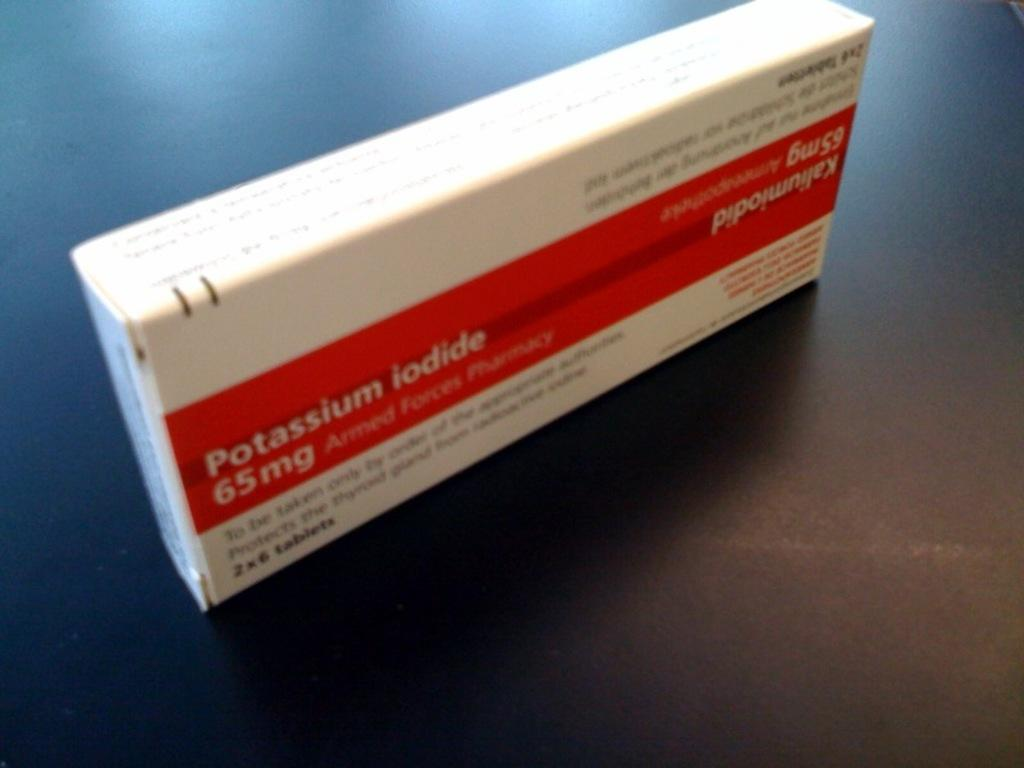<image>
Create a compact narrative representing the image presented. A box contains 65 mg of Potassium Iodide. 